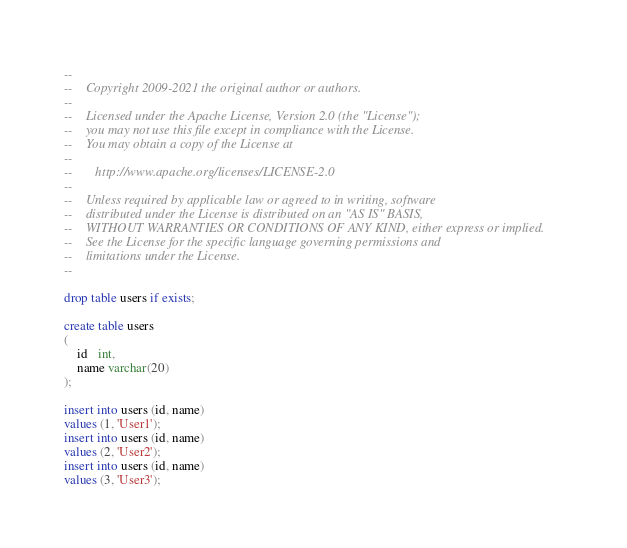Convert code to text. <code><loc_0><loc_0><loc_500><loc_500><_SQL_>--
--    Copyright 2009-2021 the original author or authors.
--
--    Licensed under the Apache License, Version 2.0 (the "License");
--    you may not use this file except in compliance with the License.
--    You may obtain a copy of the License at
--
--       http://www.apache.org/licenses/LICENSE-2.0
--
--    Unless required by applicable law or agreed to in writing, software
--    distributed under the License is distributed on an "AS IS" BASIS,
--    WITHOUT WARRANTIES OR CONDITIONS OF ANY KIND, either express or implied.
--    See the License for the specific language governing permissions and
--    limitations under the License.
--

drop table users if exists;

create table users
(
    id   int,
    name varchar(20)
);

insert into users (id, name)
values (1, 'User1');
insert into users (id, name)
values (2, 'User2');
insert into users (id, name)
values (3, 'User3');
</code> 